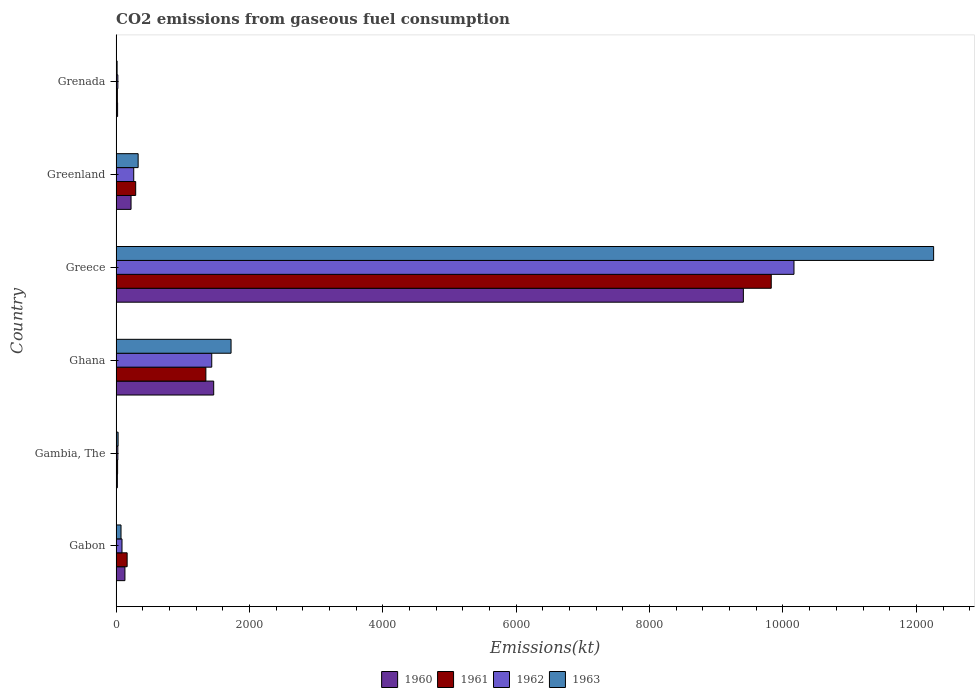Are the number of bars on each tick of the Y-axis equal?
Give a very brief answer. Yes. How many bars are there on the 2nd tick from the top?
Provide a short and direct response. 4. What is the label of the 3rd group of bars from the top?
Make the answer very short. Greece. In how many cases, is the number of bars for a given country not equal to the number of legend labels?
Your response must be concise. 0. What is the amount of CO2 emitted in 1962 in Gambia, The?
Your answer should be very brief. 25.67. Across all countries, what is the maximum amount of CO2 emitted in 1962?
Ensure brevity in your answer.  1.02e+04. Across all countries, what is the minimum amount of CO2 emitted in 1961?
Offer a terse response. 18.34. In which country was the amount of CO2 emitted in 1961 minimum?
Provide a short and direct response. Grenada. What is the total amount of CO2 emitted in 1961 in the graph?
Provide a short and direct response. 1.17e+04. What is the difference between the amount of CO2 emitted in 1962 in Ghana and that in Greece?
Provide a succinct answer. -8731.13. What is the difference between the amount of CO2 emitted in 1961 in Ghana and the amount of CO2 emitted in 1962 in Gabon?
Give a very brief answer. 1257.78. What is the average amount of CO2 emitted in 1962 per country?
Keep it short and to the point. 2000.35. What is the difference between the amount of CO2 emitted in 1961 and amount of CO2 emitted in 1962 in Greece?
Ensure brevity in your answer.  -341.03. In how many countries, is the amount of CO2 emitted in 1963 greater than 800 kt?
Offer a terse response. 2. What is the ratio of the amount of CO2 emitted in 1963 in Ghana to that in Greece?
Keep it short and to the point. 0.14. What is the difference between the highest and the second highest amount of CO2 emitted in 1962?
Make the answer very short. 8731.13. What is the difference between the highest and the lowest amount of CO2 emitted in 1960?
Give a very brief answer. 9387.52. In how many countries, is the amount of CO2 emitted in 1963 greater than the average amount of CO2 emitted in 1963 taken over all countries?
Provide a short and direct response. 1. Is the sum of the amount of CO2 emitted in 1962 in Gabon and Greenland greater than the maximum amount of CO2 emitted in 1960 across all countries?
Provide a succinct answer. No. How many bars are there?
Make the answer very short. 24. What is the difference between two consecutive major ticks on the X-axis?
Make the answer very short. 2000. Does the graph contain any zero values?
Offer a very short reply. No. Where does the legend appear in the graph?
Keep it short and to the point. Bottom center. How many legend labels are there?
Your response must be concise. 4. What is the title of the graph?
Your answer should be compact. CO2 emissions from gaseous fuel consumption. What is the label or title of the X-axis?
Your answer should be very brief. Emissions(kt). What is the Emissions(kt) in 1960 in Gabon?
Provide a short and direct response. 132.01. What is the Emissions(kt) in 1961 in Gabon?
Offer a terse response. 165.01. What is the Emissions(kt) in 1962 in Gabon?
Your answer should be compact. 88.01. What is the Emissions(kt) of 1963 in Gabon?
Offer a very short reply. 73.34. What is the Emissions(kt) in 1960 in Gambia, The?
Keep it short and to the point. 18.34. What is the Emissions(kt) of 1961 in Gambia, The?
Your response must be concise. 22. What is the Emissions(kt) in 1962 in Gambia, The?
Give a very brief answer. 25.67. What is the Emissions(kt) in 1963 in Gambia, The?
Give a very brief answer. 29.34. What is the Emissions(kt) in 1960 in Ghana?
Offer a very short reply. 1463.13. What is the Emissions(kt) of 1961 in Ghana?
Give a very brief answer. 1345.79. What is the Emissions(kt) in 1962 in Ghana?
Your response must be concise. 1433.8. What is the Emissions(kt) in 1963 in Ghana?
Your response must be concise. 1723.49. What is the Emissions(kt) of 1960 in Greece?
Your response must be concise. 9405.85. What is the Emissions(kt) in 1961 in Greece?
Your answer should be very brief. 9823.89. What is the Emissions(kt) of 1962 in Greece?
Your answer should be compact. 1.02e+04. What is the Emissions(kt) of 1963 in Greece?
Offer a terse response. 1.23e+04. What is the Emissions(kt) of 1960 in Greenland?
Your answer should be very brief. 223.69. What is the Emissions(kt) of 1961 in Greenland?
Provide a succinct answer. 293.36. What is the Emissions(kt) of 1962 in Greenland?
Keep it short and to the point. 264.02. What is the Emissions(kt) of 1963 in Greenland?
Offer a very short reply. 330.03. What is the Emissions(kt) of 1960 in Grenada?
Your answer should be compact. 22. What is the Emissions(kt) in 1961 in Grenada?
Offer a very short reply. 18.34. What is the Emissions(kt) in 1962 in Grenada?
Provide a succinct answer. 25.67. What is the Emissions(kt) in 1963 in Grenada?
Your answer should be very brief. 14.67. Across all countries, what is the maximum Emissions(kt) of 1960?
Make the answer very short. 9405.85. Across all countries, what is the maximum Emissions(kt) of 1961?
Your answer should be very brief. 9823.89. Across all countries, what is the maximum Emissions(kt) of 1962?
Your answer should be compact. 1.02e+04. Across all countries, what is the maximum Emissions(kt) of 1963?
Offer a terse response. 1.23e+04. Across all countries, what is the minimum Emissions(kt) of 1960?
Give a very brief answer. 18.34. Across all countries, what is the minimum Emissions(kt) of 1961?
Provide a succinct answer. 18.34. Across all countries, what is the minimum Emissions(kt) of 1962?
Keep it short and to the point. 25.67. Across all countries, what is the minimum Emissions(kt) in 1963?
Provide a succinct answer. 14.67. What is the total Emissions(kt) in 1960 in the graph?
Your answer should be compact. 1.13e+04. What is the total Emissions(kt) in 1961 in the graph?
Ensure brevity in your answer.  1.17e+04. What is the total Emissions(kt) in 1962 in the graph?
Offer a very short reply. 1.20e+04. What is the total Emissions(kt) in 1963 in the graph?
Offer a terse response. 1.44e+04. What is the difference between the Emissions(kt) of 1960 in Gabon and that in Gambia, The?
Your response must be concise. 113.68. What is the difference between the Emissions(kt) in 1961 in Gabon and that in Gambia, The?
Your answer should be very brief. 143.01. What is the difference between the Emissions(kt) of 1962 in Gabon and that in Gambia, The?
Provide a succinct answer. 62.34. What is the difference between the Emissions(kt) of 1963 in Gabon and that in Gambia, The?
Offer a terse response. 44. What is the difference between the Emissions(kt) of 1960 in Gabon and that in Ghana?
Offer a terse response. -1331.12. What is the difference between the Emissions(kt) in 1961 in Gabon and that in Ghana?
Offer a terse response. -1180.77. What is the difference between the Emissions(kt) in 1962 in Gabon and that in Ghana?
Offer a terse response. -1345.79. What is the difference between the Emissions(kt) of 1963 in Gabon and that in Ghana?
Your answer should be compact. -1650.15. What is the difference between the Emissions(kt) of 1960 in Gabon and that in Greece?
Keep it short and to the point. -9273.84. What is the difference between the Emissions(kt) of 1961 in Gabon and that in Greece?
Provide a short and direct response. -9658.88. What is the difference between the Emissions(kt) of 1962 in Gabon and that in Greece?
Your answer should be compact. -1.01e+04. What is the difference between the Emissions(kt) in 1963 in Gabon and that in Greece?
Ensure brevity in your answer.  -1.22e+04. What is the difference between the Emissions(kt) of 1960 in Gabon and that in Greenland?
Offer a very short reply. -91.67. What is the difference between the Emissions(kt) in 1961 in Gabon and that in Greenland?
Offer a very short reply. -128.34. What is the difference between the Emissions(kt) in 1962 in Gabon and that in Greenland?
Your answer should be very brief. -176.02. What is the difference between the Emissions(kt) in 1963 in Gabon and that in Greenland?
Your answer should be very brief. -256.69. What is the difference between the Emissions(kt) of 1960 in Gabon and that in Grenada?
Offer a very short reply. 110.01. What is the difference between the Emissions(kt) in 1961 in Gabon and that in Grenada?
Offer a very short reply. 146.68. What is the difference between the Emissions(kt) in 1962 in Gabon and that in Grenada?
Ensure brevity in your answer.  62.34. What is the difference between the Emissions(kt) of 1963 in Gabon and that in Grenada?
Offer a terse response. 58.67. What is the difference between the Emissions(kt) in 1960 in Gambia, The and that in Ghana?
Ensure brevity in your answer.  -1444.8. What is the difference between the Emissions(kt) in 1961 in Gambia, The and that in Ghana?
Your answer should be compact. -1323.79. What is the difference between the Emissions(kt) of 1962 in Gambia, The and that in Ghana?
Ensure brevity in your answer.  -1408.13. What is the difference between the Emissions(kt) in 1963 in Gambia, The and that in Ghana?
Make the answer very short. -1694.15. What is the difference between the Emissions(kt) of 1960 in Gambia, The and that in Greece?
Keep it short and to the point. -9387.52. What is the difference between the Emissions(kt) of 1961 in Gambia, The and that in Greece?
Offer a terse response. -9801.89. What is the difference between the Emissions(kt) of 1962 in Gambia, The and that in Greece?
Give a very brief answer. -1.01e+04. What is the difference between the Emissions(kt) of 1963 in Gambia, The and that in Greece?
Make the answer very short. -1.22e+04. What is the difference between the Emissions(kt) in 1960 in Gambia, The and that in Greenland?
Keep it short and to the point. -205.35. What is the difference between the Emissions(kt) of 1961 in Gambia, The and that in Greenland?
Your answer should be very brief. -271.36. What is the difference between the Emissions(kt) in 1962 in Gambia, The and that in Greenland?
Your answer should be compact. -238.35. What is the difference between the Emissions(kt) in 1963 in Gambia, The and that in Greenland?
Give a very brief answer. -300.69. What is the difference between the Emissions(kt) of 1960 in Gambia, The and that in Grenada?
Offer a terse response. -3.67. What is the difference between the Emissions(kt) in 1961 in Gambia, The and that in Grenada?
Give a very brief answer. 3.67. What is the difference between the Emissions(kt) in 1963 in Gambia, The and that in Grenada?
Your answer should be very brief. 14.67. What is the difference between the Emissions(kt) in 1960 in Ghana and that in Greece?
Ensure brevity in your answer.  -7942.72. What is the difference between the Emissions(kt) of 1961 in Ghana and that in Greece?
Offer a terse response. -8478.1. What is the difference between the Emissions(kt) of 1962 in Ghana and that in Greece?
Your response must be concise. -8731.13. What is the difference between the Emissions(kt) in 1963 in Ghana and that in Greece?
Offer a terse response. -1.05e+04. What is the difference between the Emissions(kt) of 1960 in Ghana and that in Greenland?
Offer a very short reply. 1239.45. What is the difference between the Emissions(kt) of 1961 in Ghana and that in Greenland?
Give a very brief answer. 1052.43. What is the difference between the Emissions(kt) of 1962 in Ghana and that in Greenland?
Offer a very short reply. 1169.77. What is the difference between the Emissions(kt) in 1963 in Ghana and that in Greenland?
Ensure brevity in your answer.  1393.46. What is the difference between the Emissions(kt) of 1960 in Ghana and that in Grenada?
Offer a very short reply. 1441.13. What is the difference between the Emissions(kt) in 1961 in Ghana and that in Grenada?
Give a very brief answer. 1327.45. What is the difference between the Emissions(kt) of 1962 in Ghana and that in Grenada?
Your answer should be compact. 1408.13. What is the difference between the Emissions(kt) of 1963 in Ghana and that in Grenada?
Your answer should be compact. 1708.82. What is the difference between the Emissions(kt) in 1960 in Greece and that in Greenland?
Offer a terse response. 9182.17. What is the difference between the Emissions(kt) of 1961 in Greece and that in Greenland?
Offer a terse response. 9530.53. What is the difference between the Emissions(kt) of 1962 in Greece and that in Greenland?
Make the answer very short. 9900.9. What is the difference between the Emissions(kt) of 1963 in Greece and that in Greenland?
Provide a short and direct response. 1.19e+04. What is the difference between the Emissions(kt) of 1960 in Greece and that in Grenada?
Make the answer very short. 9383.85. What is the difference between the Emissions(kt) in 1961 in Greece and that in Grenada?
Ensure brevity in your answer.  9805.56. What is the difference between the Emissions(kt) in 1962 in Greece and that in Grenada?
Ensure brevity in your answer.  1.01e+04. What is the difference between the Emissions(kt) of 1963 in Greece and that in Grenada?
Offer a very short reply. 1.22e+04. What is the difference between the Emissions(kt) in 1960 in Greenland and that in Grenada?
Give a very brief answer. 201.69. What is the difference between the Emissions(kt) of 1961 in Greenland and that in Grenada?
Offer a terse response. 275.02. What is the difference between the Emissions(kt) of 1962 in Greenland and that in Grenada?
Offer a very short reply. 238.35. What is the difference between the Emissions(kt) of 1963 in Greenland and that in Grenada?
Your answer should be compact. 315.36. What is the difference between the Emissions(kt) in 1960 in Gabon and the Emissions(kt) in 1961 in Gambia, The?
Provide a short and direct response. 110.01. What is the difference between the Emissions(kt) of 1960 in Gabon and the Emissions(kt) of 1962 in Gambia, The?
Provide a succinct answer. 106.34. What is the difference between the Emissions(kt) of 1960 in Gabon and the Emissions(kt) of 1963 in Gambia, The?
Offer a very short reply. 102.68. What is the difference between the Emissions(kt) in 1961 in Gabon and the Emissions(kt) in 1962 in Gambia, The?
Your answer should be very brief. 139.35. What is the difference between the Emissions(kt) of 1961 in Gabon and the Emissions(kt) of 1963 in Gambia, The?
Offer a terse response. 135.68. What is the difference between the Emissions(kt) in 1962 in Gabon and the Emissions(kt) in 1963 in Gambia, The?
Make the answer very short. 58.67. What is the difference between the Emissions(kt) in 1960 in Gabon and the Emissions(kt) in 1961 in Ghana?
Your answer should be very brief. -1213.78. What is the difference between the Emissions(kt) in 1960 in Gabon and the Emissions(kt) in 1962 in Ghana?
Ensure brevity in your answer.  -1301.79. What is the difference between the Emissions(kt) of 1960 in Gabon and the Emissions(kt) of 1963 in Ghana?
Make the answer very short. -1591.48. What is the difference between the Emissions(kt) in 1961 in Gabon and the Emissions(kt) in 1962 in Ghana?
Make the answer very short. -1268.78. What is the difference between the Emissions(kt) in 1961 in Gabon and the Emissions(kt) in 1963 in Ghana?
Offer a terse response. -1558.47. What is the difference between the Emissions(kt) in 1962 in Gabon and the Emissions(kt) in 1963 in Ghana?
Ensure brevity in your answer.  -1635.48. What is the difference between the Emissions(kt) in 1960 in Gabon and the Emissions(kt) in 1961 in Greece?
Your answer should be compact. -9691.88. What is the difference between the Emissions(kt) in 1960 in Gabon and the Emissions(kt) in 1962 in Greece?
Ensure brevity in your answer.  -1.00e+04. What is the difference between the Emissions(kt) of 1960 in Gabon and the Emissions(kt) of 1963 in Greece?
Make the answer very short. -1.21e+04. What is the difference between the Emissions(kt) in 1961 in Gabon and the Emissions(kt) in 1962 in Greece?
Give a very brief answer. -9999.91. What is the difference between the Emissions(kt) of 1961 in Gabon and the Emissions(kt) of 1963 in Greece?
Keep it short and to the point. -1.21e+04. What is the difference between the Emissions(kt) of 1962 in Gabon and the Emissions(kt) of 1963 in Greece?
Provide a short and direct response. -1.22e+04. What is the difference between the Emissions(kt) of 1960 in Gabon and the Emissions(kt) of 1961 in Greenland?
Offer a terse response. -161.35. What is the difference between the Emissions(kt) of 1960 in Gabon and the Emissions(kt) of 1962 in Greenland?
Make the answer very short. -132.01. What is the difference between the Emissions(kt) in 1960 in Gabon and the Emissions(kt) in 1963 in Greenland?
Your answer should be very brief. -198.02. What is the difference between the Emissions(kt) in 1961 in Gabon and the Emissions(kt) in 1962 in Greenland?
Provide a short and direct response. -99.01. What is the difference between the Emissions(kt) in 1961 in Gabon and the Emissions(kt) in 1963 in Greenland?
Your response must be concise. -165.01. What is the difference between the Emissions(kt) of 1962 in Gabon and the Emissions(kt) of 1963 in Greenland?
Ensure brevity in your answer.  -242.02. What is the difference between the Emissions(kt) in 1960 in Gabon and the Emissions(kt) in 1961 in Grenada?
Offer a terse response. 113.68. What is the difference between the Emissions(kt) in 1960 in Gabon and the Emissions(kt) in 1962 in Grenada?
Offer a very short reply. 106.34. What is the difference between the Emissions(kt) of 1960 in Gabon and the Emissions(kt) of 1963 in Grenada?
Provide a succinct answer. 117.34. What is the difference between the Emissions(kt) in 1961 in Gabon and the Emissions(kt) in 1962 in Grenada?
Offer a terse response. 139.35. What is the difference between the Emissions(kt) of 1961 in Gabon and the Emissions(kt) of 1963 in Grenada?
Make the answer very short. 150.35. What is the difference between the Emissions(kt) in 1962 in Gabon and the Emissions(kt) in 1963 in Grenada?
Ensure brevity in your answer.  73.34. What is the difference between the Emissions(kt) in 1960 in Gambia, The and the Emissions(kt) in 1961 in Ghana?
Give a very brief answer. -1327.45. What is the difference between the Emissions(kt) of 1960 in Gambia, The and the Emissions(kt) of 1962 in Ghana?
Offer a terse response. -1415.46. What is the difference between the Emissions(kt) of 1960 in Gambia, The and the Emissions(kt) of 1963 in Ghana?
Provide a succinct answer. -1705.15. What is the difference between the Emissions(kt) of 1961 in Gambia, The and the Emissions(kt) of 1962 in Ghana?
Keep it short and to the point. -1411.8. What is the difference between the Emissions(kt) in 1961 in Gambia, The and the Emissions(kt) in 1963 in Ghana?
Your answer should be compact. -1701.49. What is the difference between the Emissions(kt) of 1962 in Gambia, The and the Emissions(kt) of 1963 in Ghana?
Offer a terse response. -1697.82. What is the difference between the Emissions(kt) in 1960 in Gambia, The and the Emissions(kt) in 1961 in Greece?
Provide a succinct answer. -9805.56. What is the difference between the Emissions(kt) of 1960 in Gambia, The and the Emissions(kt) of 1962 in Greece?
Your answer should be compact. -1.01e+04. What is the difference between the Emissions(kt) of 1960 in Gambia, The and the Emissions(kt) of 1963 in Greece?
Provide a succinct answer. -1.22e+04. What is the difference between the Emissions(kt) in 1961 in Gambia, The and the Emissions(kt) in 1962 in Greece?
Provide a succinct answer. -1.01e+04. What is the difference between the Emissions(kt) of 1961 in Gambia, The and the Emissions(kt) of 1963 in Greece?
Provide a short and direct response. -1.22e+04. What is the difference between the Emissions(kt) in 1962 in Gambia, The and the Emissions(kt) in 1963 in Greece?
Make the answer very short. -1.22e+04. What is the difference between the Emissions(kt) in 1960 in Gambia, The and the Emissions(kt) in 1961 in Greenland?
Give a very brief answer. -275.02. What is the difference between the Emissions(kt) of 1960 in Gambia, The and the Emissions(kt) of 1962 in Greenland?
Provide a succinct answer. -245.69. What is the difference between the Emissions(kt) of 1960 in Gambia, The and the Emissions(kt) of 1963 in Greenland?
Keep it short and to the point. -311.69. What is the difference between the Emissions(kt) of 1961 in Gambia, The and the Emissions(kt) of 1962 in Greenland?
Your response must be concise. -242.02. What is the difference between the Emissions(kt) of 1961 in Gambia, The and the Emissions(kt) of 1963 in Greenland?
Ensure brevity in your answer.  -308.03. What is the difference between the Emissions(kt) in 1962 in Gambia, The and the Emissions(kt) in 1963 in Greenland?
Your answer should be very brief. -304.36. What is the difference between the Emissions(kt) of 1960 in Gambia, The and the Emissions(kt) of 1961 in Grenada?
Your response must be concise. 0. What is the difference between the Emissions(kt) of 1960 in Gambia, The and the Emissions(kt) of 1962 in Grenada?
Ensure brevity in your answer.  -7.33. What is the difference between the Emissions(kt) of 1960 in Gambia, The and the Emissions(kt) of 1963 in Grenada?
Make the answer very short. 3.67. What is the difference between the Emissions(kt) in 1961 in Gambia, The and the Emissions(kt) in 1962 in Grenada?
Make the answer very short. -3.67. What is the difference between the Emissions(kt) of 1961 in Gambia, The and the Emissions(kt) of 1963 in Grenada?
Offer a terse response. 7.33. What is the difference between the Emissions(kt) in 1962 in Gambia, The and the Emissions(kt) in 1963 in Grenada?
Provide a short and direct response. 11. What is the difference between the Emissions(kt) of 1960 in Ghana and the Emissions(kt) of 1961 in Greece?
Provide a short and direct response. -8360.76. What is the difference between the Emissions(kt) in 1960 in Ghana and the Emissions(kt) in 1962 in Greece?
Keep it short and to the point. -8701.79. What is the difference between the Emissions(kt) in 1960 in Ghana and the Emissions(kt) in 1963 in Greece?
Offer a terse response. -1.08e+04. What is the difference between the Emissions(kt) in 1961 in Ghana and the Emissions(kt) in 1962 in Greece?
Your answer should be very brief. -8819.14. What is the difference between the Emissions(kt) in 1961 in Ghana and the Emissions(kt) in 1963 in Greece?
Ensure brevity in your answer.  -1.09e+04. What is the difference between the Emissions(kt) of 1962 in Ghana and the Emissions(kt) of 1963 in Greece?
Offer a very short reply. -1.08e+04. What is the difference between the Emissions(kt) in 1960 in Ghana and the Emissions(kt) in 1961 in Greenland?
Your answer should be very brief. 1169.77. What is the difference between the Emissions(kt) in 1960 in Ghana and the Emissions(kt) in 1962 in Greenland?
Your answer should be compact. 1199.11. What is the difference between the Emissions(kt) in 1960 in Ghana and the Emissions(kt) in 1963 in Greenland?
Give a very brief answer. 1133.1. What is the difference between the Emissions(kt) of 1961 in Ghana and the Emissions(kt) of 1962 in Greenland?
Provide a succinct answer. 1081.77. What is the difference between the Emissions(kt) of 1961 in Ghana and the Emissions(kt) of 1963 in Greenland?
Ensure brevity in your answer.  1015.76. What is the difference between the Emissions(kt) in 1962 in Ghana and the Emissions(kt) in 1963 in Greenland?
Your answer should be very brief. 1103.77. What is the difference between the Emissions(kt) of 1960 in Ghana and the Emissions(kt) of 1961 in Grenada?
Ensure brevity in your answer.  1444.8. What is the difference between the Emissions(kt) of 1960 in Ghana and the Emissions(kt) of 1962 in Grenada?
Make the answer very short. 1437.46. What is the difference between the Emissions(kt) of 1960 in Ghana and the Emissions(kt) of 1963 in Grenada?
Offer a very short reply. 1448.46. What is the difference between the Emissions(kt) in 1961 in Ghana and the Emissions(kt) in 1962 in Grenada?
Your response must be concise. 1320.12. What is the difference between the Emissions(kt) of 1961 in Ghana and the Emissions(kt) of 1963 in Grenada?
Make the answer very short. 1331.12. What is the difference between the Emissions(kt) in 1962 in Ghana and the Emissions(kt) in 1963 in Grenada?
Your answer should be compact. 1419.13. What is the difference between the Emissions(kt) in 1960 in Greece and the Emissions(kt) in 1961 in Greenland?
Provide a succinct answer. 9112.5. What is the difference between the Emissions(kt) in 1960 in Greece and the Emissions(kt) in 1962 in Greenland?
Your response must be concise. 9141.83. What is the difference between the Emissions(kt) in 1960 in Greece and the Emissions(kt) in 1963 in Greenland?
Keep it short and to the point. 9075.83. What is the difference between the Emissions(kt) in 1961 in Greece and the Emissions(kt) in 1962 in Greenland?
Provide a succinct answer. 9559.87. What is the difference between the Emissions(kt) in 1961 in Greece and the Emissions(kt) in 1963 in Greenland?
Your answer should be compact. 9493.86. What is the difference between the Emissions(kt) in 1962 in Greece and the Emissions(kt) in 1963 in Greenland?
Offer a terse response. 9834.89. What is the difference between the Emissions(kt) of 1960 in Greece and the Emissions(kt) of 1961 in Grenada?
Your response must be concise. 9387.52. What is the difference between the Emissions(kt) in 1960 in Greece and the Emissions(kt) in 1962 in Grenada?
Provide a short and direct response. 9380.19. What is the difference between the Emissions(kt) in 1960 in Greece and the Emissions(kt) in 1963 in Grenada?
Keep it short and to the point. 9391.19. What is the difference between the Emissions(kt) in 1961 in Greece and the Emissions(kt) in 1962 in Grenada?
Keep it short and to the point. 9798.22. What is the difference between the Emissions(kt) in 1961 in Greece and the Emissions(kt) in 1963 in Grenada?
Your answer should be compact. 9809.23. What is the difference between the Emissions(kt) in 1962 in Greece and the Emissions(kt) in 1963 in Grenada?
Offer a terse response. 1.02e+04. What is the difference between the Emissions(kt) of 1960 in Greenland and the Emissions(kt) of 1961 in Grenada?
Provide a short and direct response. 205.35. What is the difference between the Emissions(kt) of 1960 in Greenland and the Emissions(kt) of 1962 in Grenada?
Offer a terse response. 198.02. What is the difference between the Emissions(kt) of 1960 in Greenland and the Emissions(kt) of 1963 in Grenada?
Offer a very short reply. 209.02. What is the difference between the Emissions(kt) in 1961 in Greenland and the Emissions(kt) in 1962 in Grenada?
Make the answer very short. 267.69. What is the difference between the Emissions(kt) of 1961 in Greenland and the Emissions(kt) of 1963 in Grenada?
Provide a succinct answer. 278.69. What is the difference between the Emissions(kt) of 1962 in Greenland and the Emissions(kt) of 1963 in Grenada?
Provide a short and direct response. 249.36. What is the average Emissions(kt) of 1960 per country?
Ensure brevity in your answer.  1877.5. What is the average Emissions(kt) of 1961 per country?
Provide a short and direct response. 1944.73. What is the average Emissions(kt) in 1962 per country?
Give a very brief answer. 2000.35. What is the average Emissions(kt) of 1963 per country?
Your response must be concise. 2404.94. What is the difference between the Emissions(kt) in 1960 and Emissions(kt) in 1961 in Gabon?
Provide a short and direct response. -33. What is the difference between the Emissions(kt) in 1960 and Emissions(kt) in 1962 in Gabon?
Keep it short and to the point. 44. What is the difference between the Emissions(kt) in 1960 and Emissions(kt) in 1963 in Gabon?
Offer a terse response. 58.67. What is the difference between the Emissions(kt) in 1961 and Emissions(kt) in 1962 in Gabon?
Your answer should be compact. 77.01. What is the difference between the Emissions(kt) in 1961 and Emissions(kt) in 1963 in Gabon?
Your answer should be compact. 91.67. What is the difference between the Emissions(kt) of 1962 and Emissions(kt) of 1963 in Gabon?
Provide a succinct answer. 14.67. What is the difference between the Emissions(kt) in 1960 and Emissions(kt) in 1961 in Gambia, The?
Keep it short and to the point. -3.67. What is the difference between the Emissions(kt) of 1960 and Emissions(kt) of 1962 in Gambia, The?
Keep it short and to the point. -7.33. What is the difference between the Emissions(kt) in 1960 and Emissions(kt) in 1963 in Gambia, The?
Give a very brief answer. -11. What is the difference between the Emissions(kt) in 1961 and Emissions(kt) in 1962 in Gambia, The?
Make the answer very short. -3.67. What is the difference between the Emissions(kt) in 1961 and Emissions(kt) in 1963 in Gambia, The?
Keep it short and to the point. -7.33. What is the difference between the Emissions(kt) of 1962 and Emissions(kt) of 1963 in Gambia, The?
Your response must be concise. -3.67. What is the difference between the Emissions(kt) in 1960 and Emissions(kt) in 1961 in Ghana?
Your response must be concise. 117.34. What is the difference between the Emissions(kt) of 1960 and Emissions(kt) of 1962 in Ghana?
Offer a very short reply. 29.34. What is the difference between the Emissions(kt) in 1960 and Emissions(kt) in 1963 in Ghana?
Offer a very short reply. -260.36. What is the difference between the Emissions(kt) of 1961 and Emissions(kt) of 1962 in Ghana?
Offer a very short reply. -88.01. What is the difference between the Emissions(kt) of 1961 and Emissions(kt) of 1963 in Ghana?
Give a very brief answer. -377.7. What is the difference between the Emissions(kt) in 1962 and Emissions(kt) in 1963 in Ghana?
Your answer should be compact. -289.69. What is the difference between the Emissions(kt) of 1960 and Emissions(kt) of 1961 in Greece?
Your answer should be compact. -418.04. What is the difference between the Emissions(kt) of 1960 and Emissions(kt) of 1962 in Greece?
Your response must be concise. -759.07. What is the difference between the Emissions(kt) of 1960 and Emissions(kt) of 1963 in Greece?
Your answer should be very brief. -2852.93. What is the difference between the Emissions(kt) of 1961 and Emissions(kt) of 1962 in Greece?
Your answer should be very brief. -341.03. What is the difference between the Emissions(kt) of 1961 and Emissions(kt) of 1963 in Greece?
Your answer should be compact. -2434.89. What is the difference between the Emissions(kt) of 1962 and Emissions(kt) of 1963 in Greece?
Provide a succinct answer. -2093.86. What is the difference between the Emissions(kt) in 1960 and Emissions(kt) in 1961 in Greenland?
Provide a succinct answer. -69.67. What is the difference between the Emissions(kt) of 1960 and Emissions(kt) of 1962 in Greenland?
Provide a short and direct response. -40.34. What is the difference between the Emissions(kt) of 1960 and Emissions(kt) of 1963 in Greenland?
Provide a succinct answer. -106.34. What is the difference between the Emissions(kt) of 1961 and Emissions(kt) of 1962 in Greenland?
Offer a terse response. 29.34. What is the difference between the Emissions(kt) in 1961 and Emissions(kt) in 1963 in Greenland?
Ensure brevity in your answer.  -36.67. What is the difference between the Emissions(kt) in 1962 and Emissions(kt) in 1963 in Greenland?
Keep it short and to the point. -66.01. What is the difference between the Emissions(kt) of 1960 and Emissions(kt) of 1961 in Grenada?
Give a very brief answer. 3.67. What is the difference between the Emissions(kt) of 1960 and Emissions(kt) of 1962 in Grenada?
Offer a terse response. -3.67. What is the difference between the Emissions(kt) in 1960 and Emissions(kt) in 1963 in Grenada?
Provide a succinct answer. 7.33. What is the difference between the Emissions(kt) of 1961 and Emissions(kt) of 1962 in Grenada?
Provide a succinct answer. -7.33. What is the difference between the Emissions(kt) in 1961 and Emissions(kt) in 1963 in Grenada?
Provide a short and direct response. 3.67. What is the difference between the Emissions(kt) of 1962 and Emissions(kt) of 1963 in Grenada?
Provide a succinct answer. 11. What is the ratio of the Emissions(kt) of 1960 in Gabon to that in Gambia, The?
Make the answer very short. 7.2. What is the ratio of the Emissions(kt) of 1961 in Gabon to that in Gambia, The?
Offer a very short reply. 7.5. What is the ratio of the Emissions(kt) of 1962 in Gabon to that in Gambia, The?
Offer a very short reply. 3.43. What is the ratio of the Emissions(kt) in 1963 in Gabon to that in Gambia, The?
Give a very brief answer. 2.5. What is the ratio of the Emissions(kt) in 1960 in Gabon to that in Ghana?
Make the answer very short. 0.09. What is the ratio of the Emissions(kt) of 1961 in Gabon to that in Ghana?
Keep it short and to the point. 0.12. What is the ratio of the Emissions(kt) of 1962 in Gabon to that in Ghana?
Offer a terse response. 0.06. What is the ratio of the Emissions(kt) in 1963 in Gabon to that in Ghana?
Keep it short and to the point. 0.04. What is the ratio of the Emissions(kt) of 1960 in Gabon to that in Greece?
Provide a short and direct response. 0.01. What is the ratio of the Emissions(kt) in 1961 in Gabon to that in Greece?
Your response must be concise. 0.02. What is the ratio of the Emissions(kt) in 1962 in Gabon to that in Greece?
Keep it short and to the point. 0.01. What is the ratio of the Emissions(kt) in 1963 in Gabon to that in Greece?
Provide a succinct answer. 0.01. What is the ratio of the Emissions(kt) of 1960 in Gabon to that in Greenland?
Your response must be concise. 0.59. What is the ratio of the Emissions(kt) of 1961 in Gabon to that in Greenland?
Ensure brevity in your answer.  0.56. What is the ratio of the Emissions(kt) in 1962 in Gabon to that in Greenland?
Make the answer very short. 0.33. What is the ratio of the Emissions(kt) in 1963 in Gabon to that in Greenland?
Your answer should be compact. 0.22. What is the ratio of the Emissions(kt) of 1961 in Gabon to that in Grenada?
Ensure brevity in your answer.  9. What is the ratio of the Emissions(kt) in 1962 in Gabon to that in Grenada?
Your answer should be compact. 3.43. What is the ratio of the Emissions(kt) in 1960 in Gambia, The to that in Ghana?
Your answer should be compact. 0.01. What is the ratio of the Emissions(kt) in 1961 in Gambia, The to that in Ghana?
Provide a succinct answer. 0.02. What is the ratio of the Emissions(kt) of 1962 in Gambia, The to that in Ghana?
Offer a terse response. 0.02. What is the ratio of the Emissions(kt) of 1963 in Gambia, The to that in Ghana?
Offer a terse response. 0.02. What is the ratio of the Emissions(kt) of 1960 in Gambia, The to that in Greece?
Offer a terse response. 0. What is the ratio of the Emissions(kt) of 1961 in Gambia, The to that in Greece?
Provide a short and direct response. 0. What is the ratio of the Emissions(kt) in 1962 in Gambia, The to that in Greece?
Make the answer very short. 0. What is the ratio of the Emissions(kt) of 1963 in Gambia, The to that in Greece?
Offer a very short reply. 0. What is the ratio of the Emissions(kt) in 1960 in Gambia, The to that in Greenland?
Give a very brief answer. 0.08. What is the ratio of the Emissions(kt) of 1961 in Gambia, The to that in Greenland?
Offer a terse response. 0.07. What is the ratio of the Emissions(kt) in 1962 in Gambia, The to that in Greenland?
Your answer should be compact. 0.1. What is the ratio of the Emissions(kt) in 1963 in Gambia, The to that in Greenland?
Keep it short and to the point. 0.09. What is the ratio of the Emissions(kt) of 1960 in Gambia, The to that in Grenada?
Your answer should be compact. 0.83. What is the ratio of the Emissions(kt) of 1962 in Gambia, The to that in Grenada?
Keep it short and to the point. 1. What is the ratio of the Emissions(kt) in 1960 in Ghana to that in Greece?
Provide a succinct answer. 0.16. What is the ratio of the Emissions(kt) of 1961 in Ghana to that in Greece?
Make the answer very short. 0.14. What is the ratio of the Emissions(kt) of 1962 in Ghana to that in Greece?
Provide a short and direct response. 0.14. What is the ratio of the Emissions(kt) of 1963 in Ghana to that in Greece?
Provide a succinct answer. 0.14. What is the ratio of the Emissions(kt) of 1960 in Ghana to that in Greenland?
Provide a succinct answer. 6.54. What is the ratio of the Emissions(kt) of 1961 in Ghana to that in Greenland?
Offer a terse response. 4.59. What is the ratio of the Emissions(kt) of 1962 in Ghana to that in Greenland?
Keep it short and to the point. 5.43. What is the ratio of the Emissions(kt) in 1963 in Ghana to that in Greenland?
Offer a very short reply. 5.22. What is the ratio of the Emissions(kt) of 1960 in Ghana to that in Grenada?
Make the answer very short. 66.5. What is the ratio of the Emissions(kt) of 1961 in Ghana to that in Grenada?
Your answer should be very brief. 73.4. What is the ratio of the Emissions(kt) in 1962 in Ghana to that in Grenada?
Provide a succinct answer. 55.86. What is the ratio of the Emissions(kt) in 1963 in Ghana to that in Grenada?
Your response must be concise. 117.5. What is the ratio of the Emissions(kt) of 1960 in Greece to that in Greenland?
Your answer should be very brief. 42.05. What is the ratio of the Emissions(kt) in 1961 in Greece to that in Greenland?
Your response must be concise. 33.49. What is the ratio of the Emissions(kt) in 1962 in Greece to that in Greenland?
Ensure brevity in your answer.  38.5. What is the ratio of the Emissions(kt) of 1963 in Greece to that in Greenland?
Your answer should be very brief. 37.14. What is the ratio of the Emissions(kt) of 1960 in Greece to that in Grenada?
Your answer should be compact. 427.5. What is the ratio of the Emissions(kt) of 1961 in Greece to that in Grenada?
Offer a very short reply. 535.8. What is the ratio of the Emissions(kt) in 1962 in Greece to that in Grenada?
Offer a terse response. 396. What is the ratio of the Emissions(kt) of 1963 in Greece to that in Grenada?
Keep it short and to the point. 835.75. What is the ratio of the Emissions(kt) in 1960 in Greenland to that in Grenada?
Give a very brief answer. 10.17. What is the ratio of the Emissions(kt) in 1961 in Greenland to that in Grenada?
Provide a short and direct response. 16. What is the ratio of the Emissions(kt) of 1962 in Greenland to that in Grenada?
Your answer should be very brief. 10.29. What is the difference between the highest and the second highest Emissions(kt) in 1960?
Your answer should be compact. 7942.72. What is the difference between the highest and the second highest Emissions(kt) in 1961?
Provide a short and direct response. 8478.1. What is the difference between the highest and the second highest Emissions(kt) in 1962?
Your answer should be compact. 8731.13. What is the difference between the highest and the second highest Emissions(kt) in 1963?
Keep it short and to the point. 1.05e+04. What is the difference between the highest and the lowest Emissions(kt) in 1960?
Your response must be concise. 9387.52. What is the difference between the highest and the lowest Emissions(kt) of 1961?
Your answer should be compact. 9805.56. What is the difference between the highest and the lowest Emissions(kt) of 1962?
Offer a very short reply. 1.01e+04. What is the difference between the highest and the lowest Emissions(kt) of 1963?
Make the answer very short. 1.22e+04. 